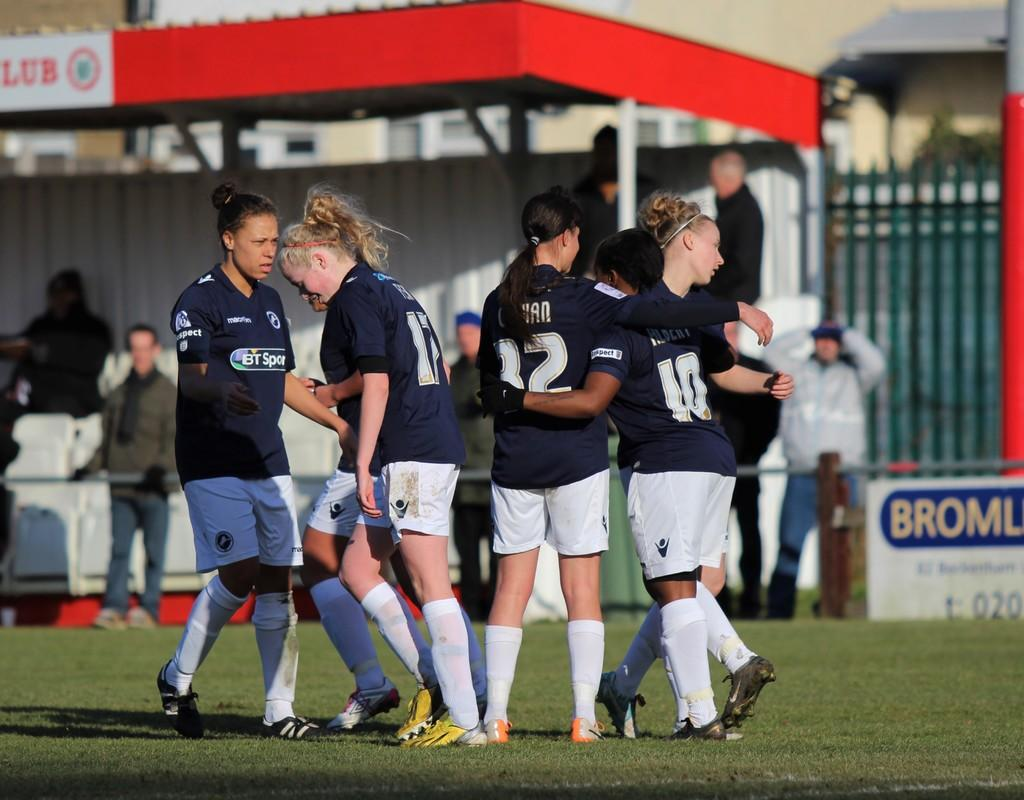<image>
Present a compact description of the photo's key features. Player number 10 has her arm around another player's waist. 